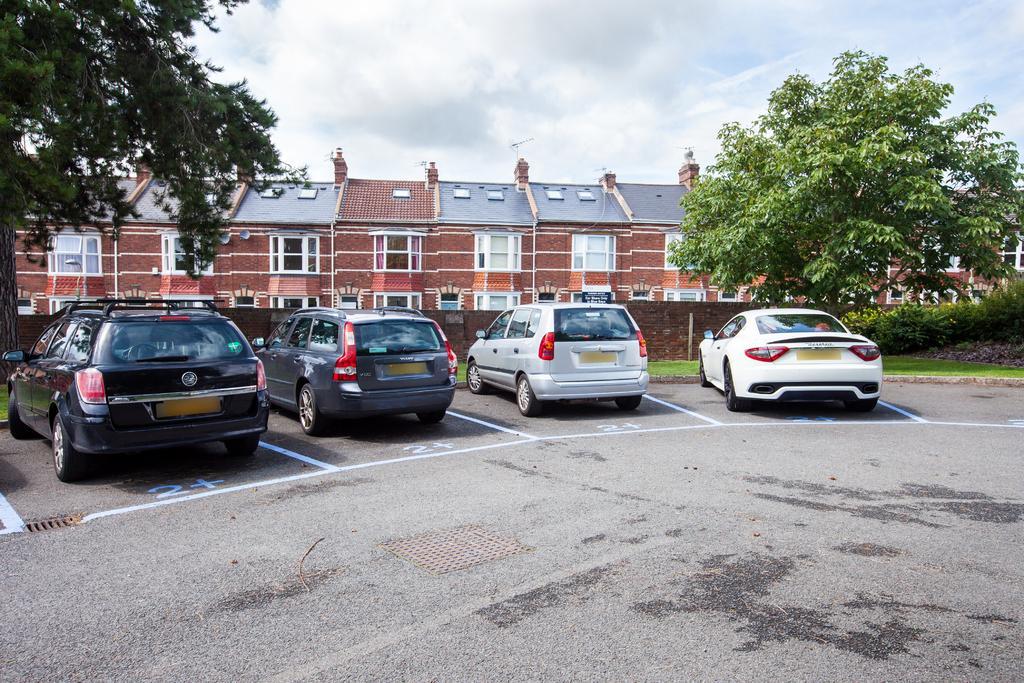Describe this image in one or two sentences. In the middle of the image we can see some vehicles on the road. Behind the vehicles we can see a wall, plants and trees. Behind the wall we can see a building. At the top of the image we can see some clouds in the sky. 